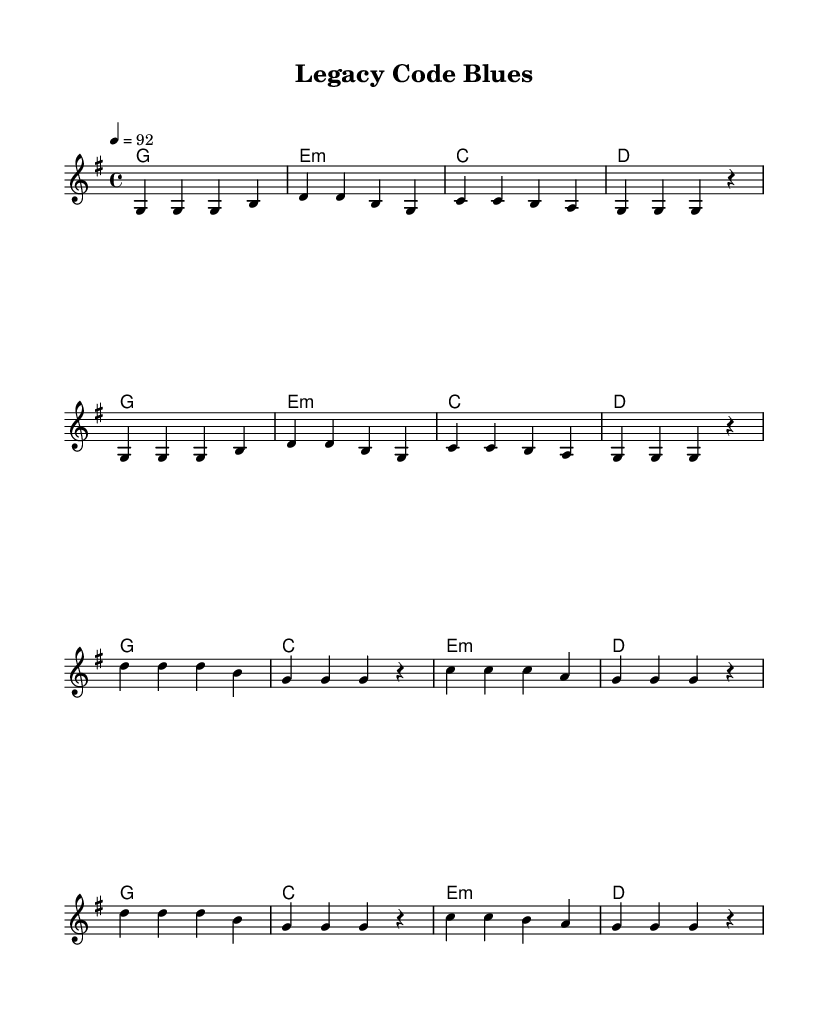What is the key signature of this music? The key signature is G major, which has one sharp (F#). This can be determined from the global section where it is specified.
Answer: G major What is the time signature of this music? The time signature indicated in the global section is 4/4, which means there are four beats per measure, and the quarter note gets one beat.
Answer: 4/4 What is the tempo marking? The tempo marking is specified as quarter note equals 92 beats per minute in the global section. This defines the speed at which the piece should be played.
Answer: 92 How many measures are in the verse? The verse consists of four lines of music, and each line contains two measures, resulting in a total of eight measures.
Answer: Eight What chord follows the second line of the verse? The chord following the second line of the verse is D major, as indicated in the chord section where the order of the chords corresponds with the lines of lyrics and melody.
Answer: D major What is the repeated lyric in the chorus? The repeated lyric in the chorus is "g g g r," which appears multiple times, indicating the same musical phrase is sung again.
Answer: g g g r What does the term "Git push" refer to in context? "Git push" is a term used in software development for uploading changes to a repository; its inclusion highlights the struggle between traditional coding and modern technologies in the song's narrative.
Answer: Git push 